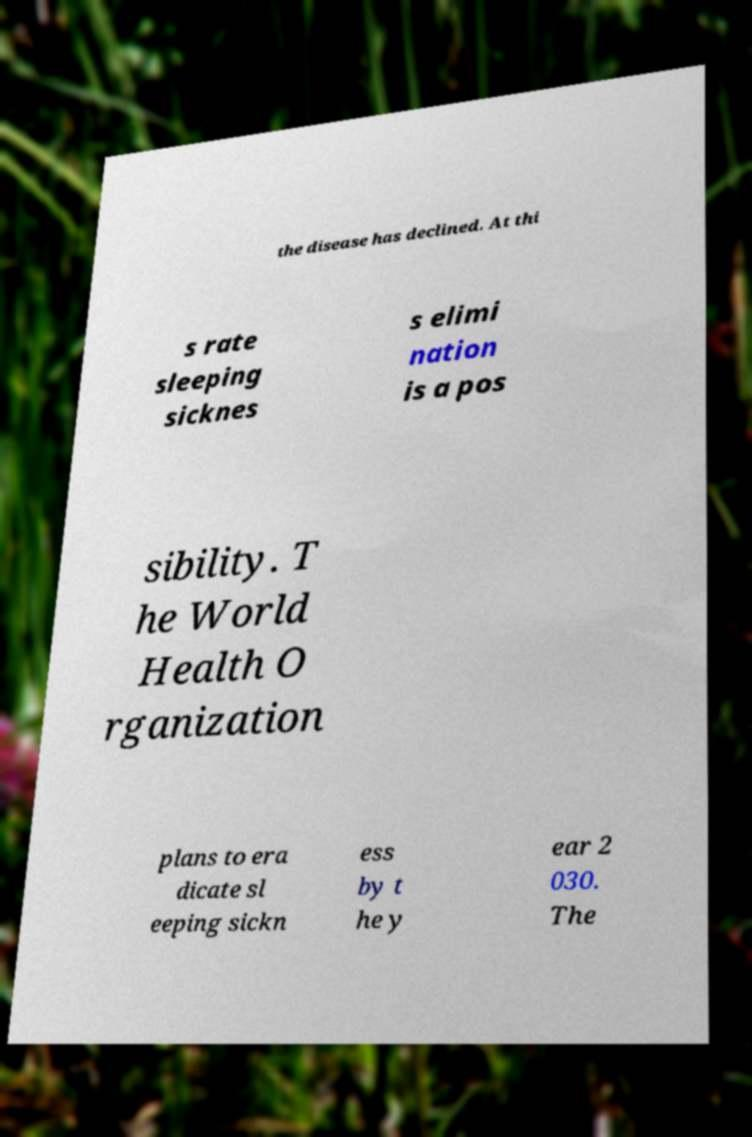What messages or text are displayed in this image? I need them in a readable, typed format. the disease has declined. At thi s rate sleeping sicknes s elimi nation is a pos sibility. T he World Health O rganization plans to era dicate sl eeping sickn ess by t he y ear 2 030. The 